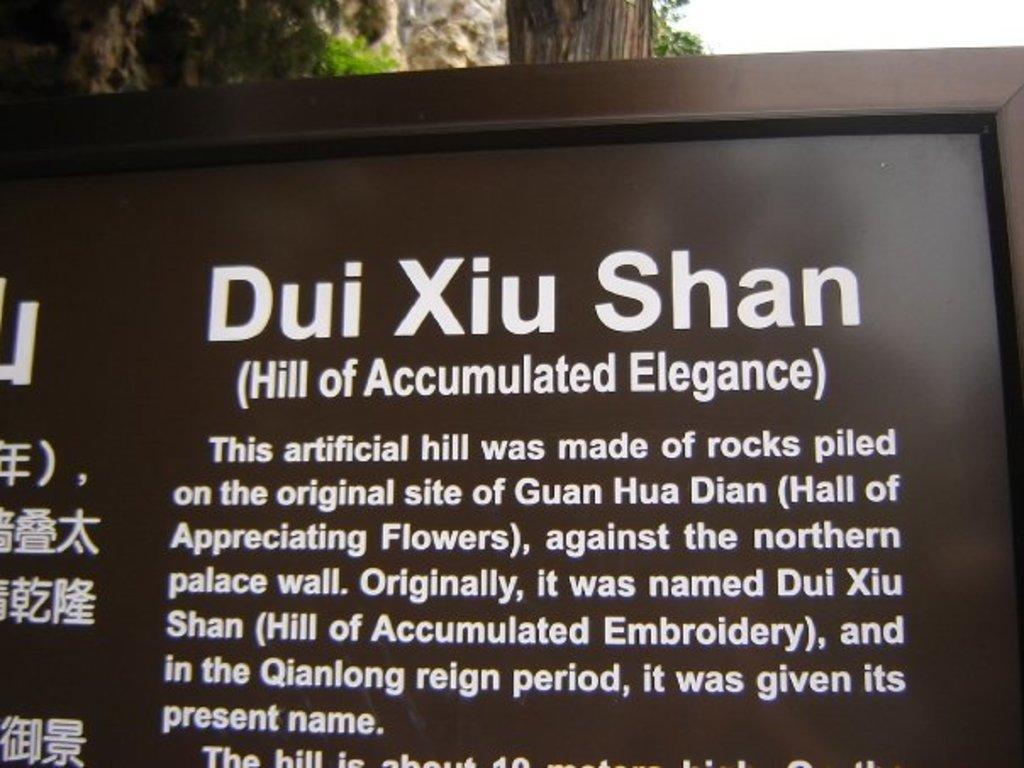Can you describe this image briefly? In this image I can see a brown colored board and on it I can see something is written with white color. In the background I can see few trees which are green and brown in color, a rocky mountain and the sky. 